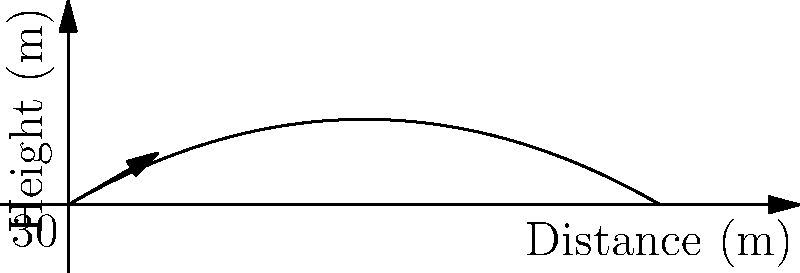During a murder mystery event, you need to simulate a dagger throw for dramatic effect. If a prop dagger is thrown from ground level with an initial velocity of 15 m/s at an angle of 30° above the horizontal, what is the maximum height reached by the dagger? (Assume air resistance is negligible and use $g = 9.8 \text{ m/s}^2$) To find the maximum height, we can follow these steps:

1) The vertical component of the initial velocity is:
   $v_{0y} = v_0 \sin \theta = 15 \text{ m/s} \cdot \sin 30° = 7.5 \text{ m/s}$

2) The time to reach the maximum height is when the vertical velocity becomes zero:
   $t_{max} = \frac{v_{0y}}{g} = \frac{7.5 \text{ m/s}}{9.8 \text{ m/s}^2} = 0.765 \text{ s}$

3) The maximum height can be calculated using the equation:
   $h_{max} = v_{0y}t - \frac{1}{2}gt^2$

4) Substituting the values:
   $h_{max} = (7.5 \text{ m/s})(0.765 \text{ s}) - \frac{1}{2}(9.8 \text{ m/s}^2)(0.765 \text{ s})^2$

5) Calculating:
   $h_{max} = 5.74 \text{ m} - 2.87 \text{ m} = 2.87 \text{ m}$

Therefore, the maximum height reached by the dagger is approximately 2.87 meters.
Answer: 2.87 m 